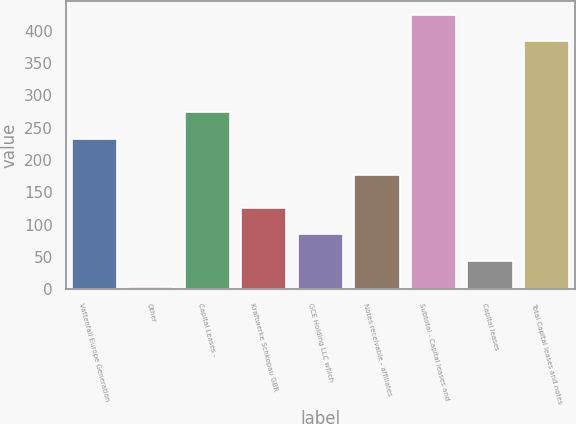Convert chart. <chart><loc_0><loc_0><loc_500><loc_500><bar_chart><fcel>Vattenfall Europe Generation<fcel>Other<fcel>Capital Leases -<fcel>Kraftwerke Schkopau GBR<fcel>GCE Holding LLC which<fcel>Notes receivable - affiliates<fcel>Subtotal - Capital leases and<fcel>Capital leases<fcel>Total Capital leases and notes<nl><fcel>233<fcel>3<fcel>274<fcel>126<fcel>85<fcel>177<fcel>425<fcel>44<fcel>384<nl></chart> 